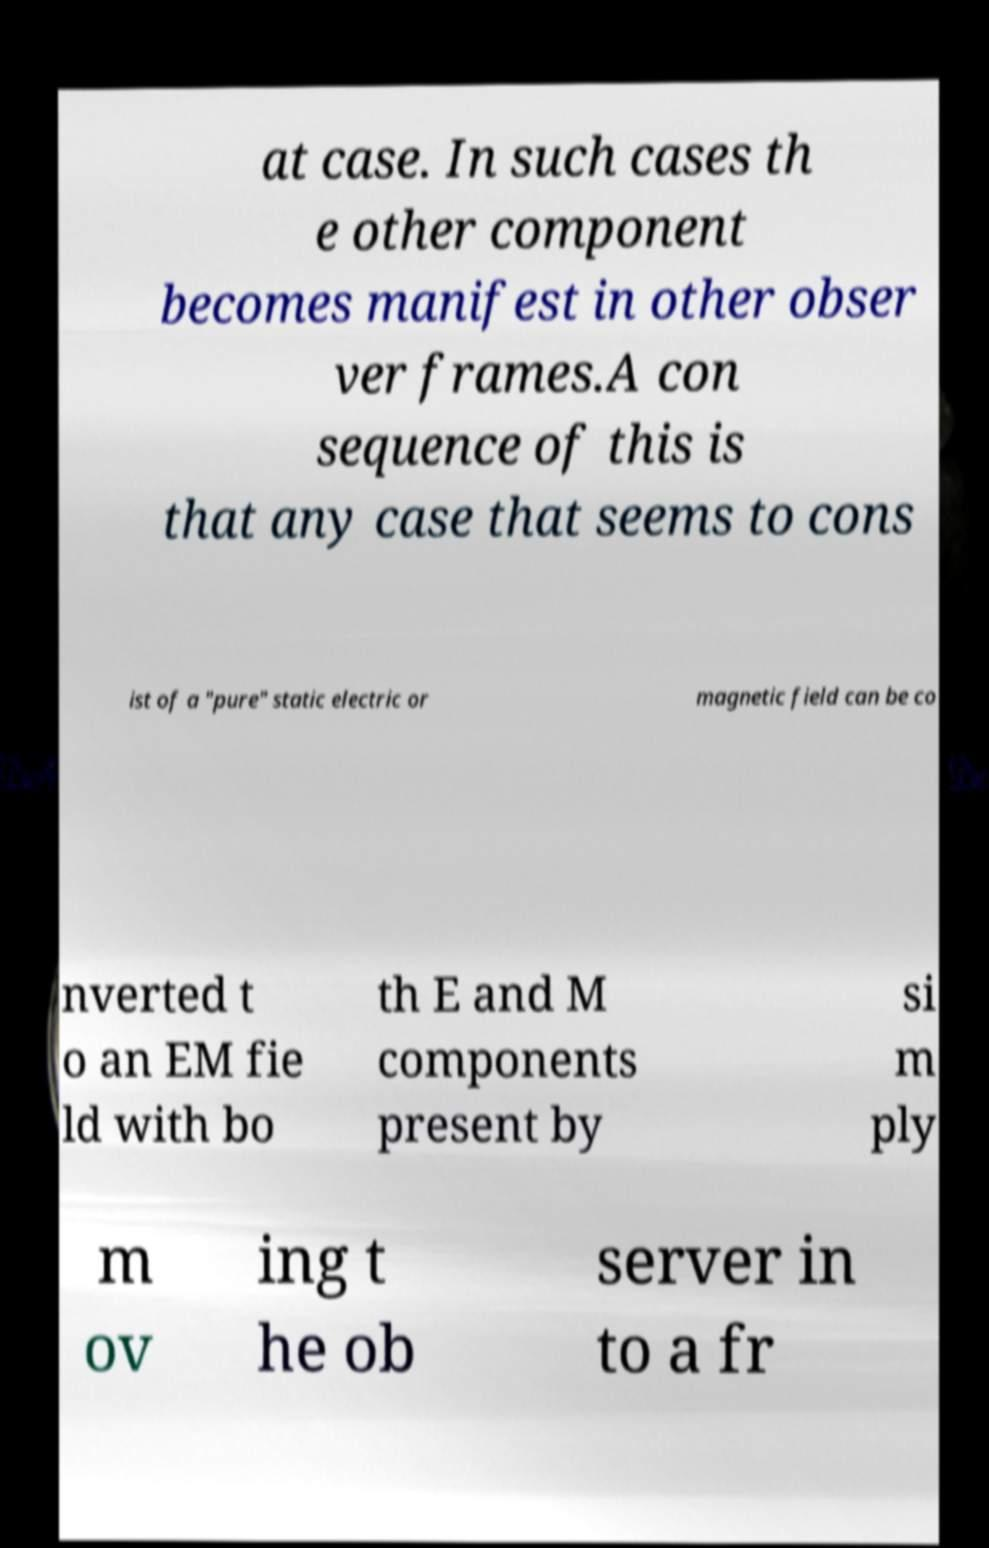Could you assist in decoding the text presented in this image and type it out clearly? at case. In such cases th e other component becomes manifest in other obser ver frames.A con sequence of this is that any case that seems to cons ist of a "pure" static electric or magnetic field can be co nverted t o an EM fie ld with bo th E and M components present by si m ply m ov ing t he ob server in to a fr 